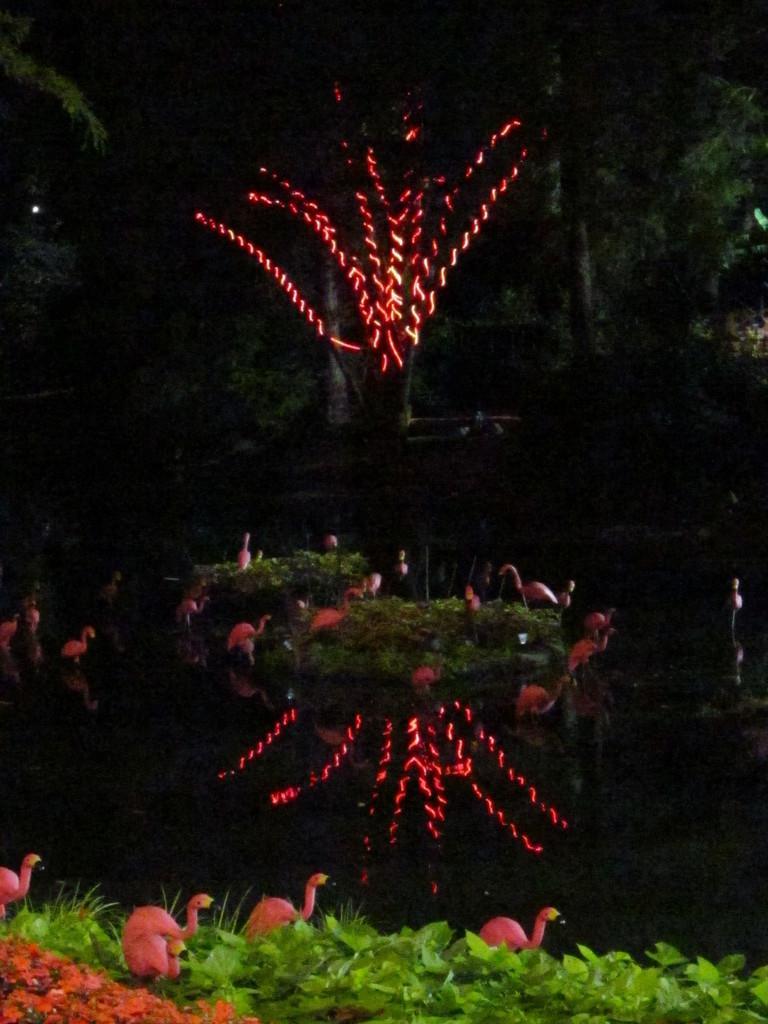In one or two sentences, can you explain what this image depicts? Bottom of the image there is grass and there are some birds. In the middle of the image there is a tree and lights. 